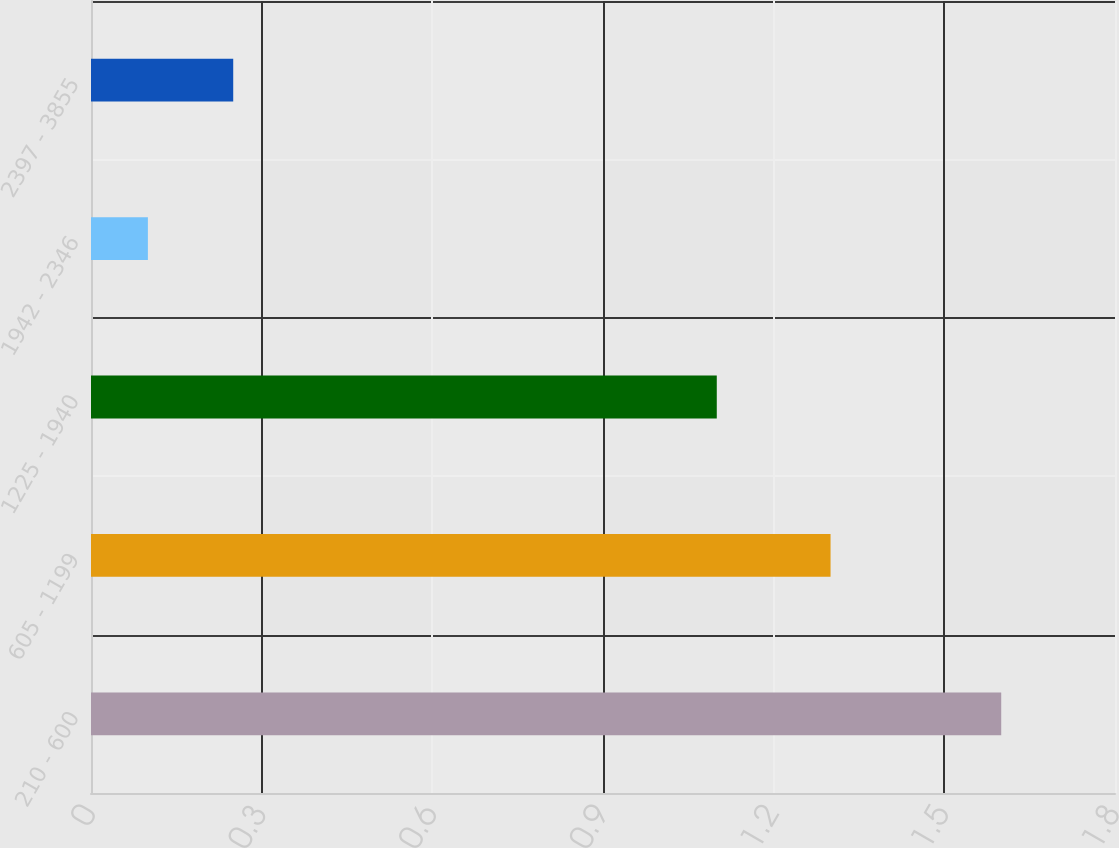Convert chart. <chart><loc_0><loc_0><loc_500><loc_500><bar_chart><fcel>210 - 600<fcel>605 - 1199<fcel>1225 - 1940<fcel>1942 - 2346<fcel>2397 - 3855<nl><fcel>1.6<fcel>1.3<fcel>1.1<fcel>0.1<fcel>0.25<nl></chart> 